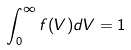Convert formula to latex. <formula><loc_0><loc_0><loc_500><loc_500>\int _ { 0 } ^ { \infty } f ( V ) d V = 1</formula> 